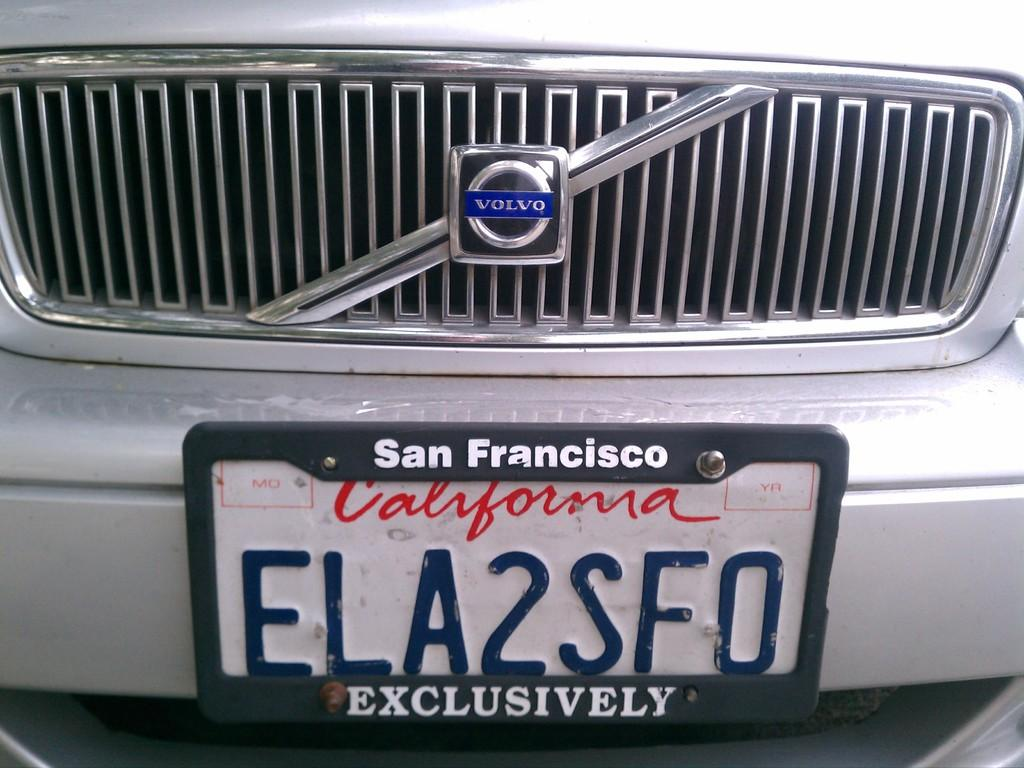<image>
Give a short and clear explanation of the subsequent image. a volvo car with california licence plate ela2sf0 